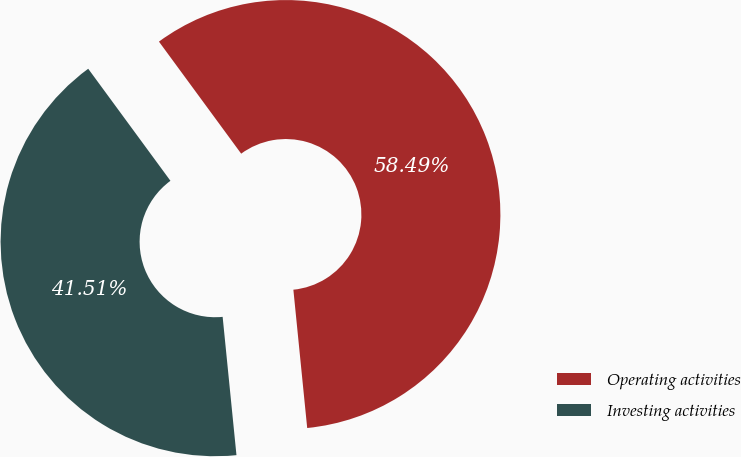Convert chart to OTSL. <chart><loc_0><loc_0><loc_500><loc_500><pie_chart><fcel>Operating activities<fcel>Investing activities<nl><fcel>58.49%<fcel>41.51%<nl></chart> 